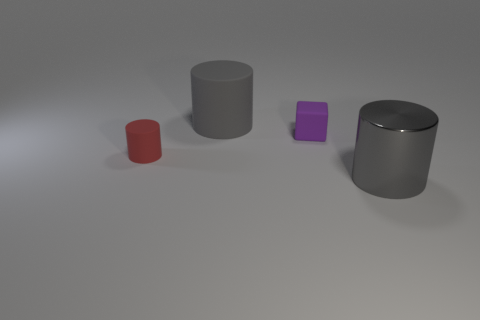What material is the tiny red cylinder?
Make the answer very short. Rubber. There is a cylinder that is both left of the gray metallic cylinder and right of the small red cylinder; what is its size?
Your answer should be very brief. Large. There is a object that is the same color as the metallic cylinder; what material is it?
Ensure brevity in your answer.  Rubber. How many big gray shiny things are there?
Make the answer very short. 1. Are there fewer blocks than small red metallic spheres?
Give a very brief answer. No. What material is the purple block that is the same size as the red cylinder?
Provide a short and direct response. Rubber. How many objects are big red cylinders or tiny matte objects?
Offer a terse response. 2. How many cylinders are on the right side of the small red matte cylinder and behind the gray metal object?
Ensure brevity in your answer.  1. Is the number of big objects that are on the left side of the tiny purple thing less than the number of tiny red things?
Make the answer very short. No. The other gray thing that is the same size as the gray matte thing is what shape?
Keep it short and to the point. Cylinder. 